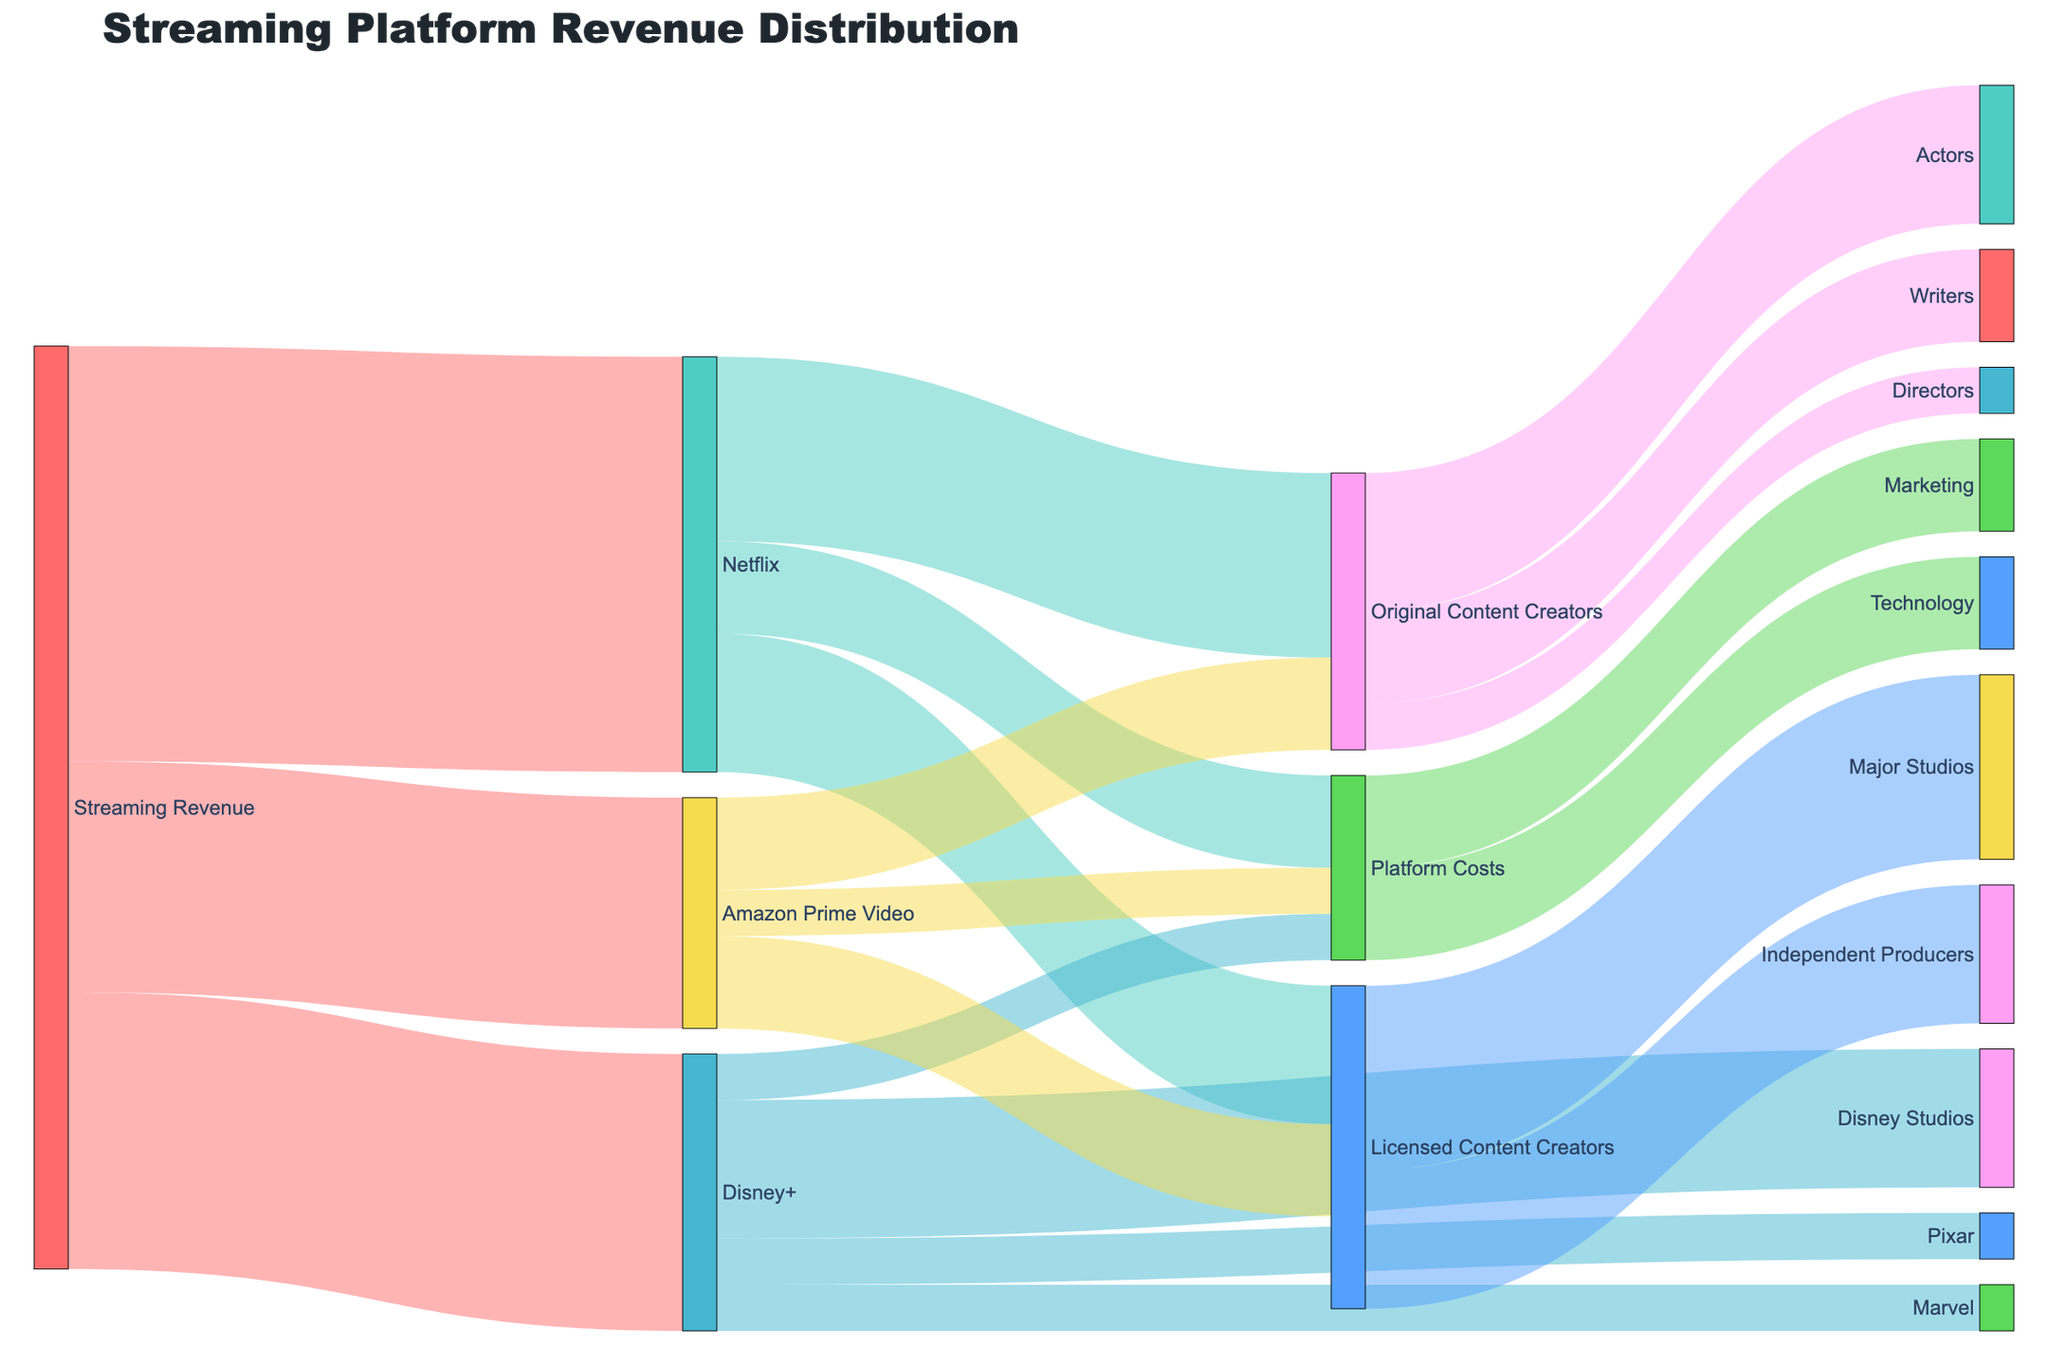What's the total revenue from Streaming Revenue? Summing all values coming from "Streaming Revenue": 45 (Netflix) + 30 (Disney+) + 25 (Amazon Prime Video) = 100
Answer: 100 How much revenue does Netflix generate for Original Content Creators? The value connecting Netflix to Original Content Creators is 20.
Answer: 20 Which platform allocates the most funds to their own Platform Costs? Comparing the values for Platform Costs: Netflix (10), Disney+ (5), Amazon Prime Video (5). Netflix allocates the most.
Answer: Netflix What is the total revenue allocated to Licensed Content Creators across all platforms? Summing all values going to Licensed Content Creators: Netflix (15) + Amazon Prime Video (10) = 25
Answer: 25 What is the difference in funding between Disney Studios and Pixar from Disney+? The value for Disney Studios is 15, and for Pixar is 5. The difference is 15 - 5 = 10.
Answer: 10 What is the proportion of Amazon Prime Video's revenue that goes to Original Content Creators? The value for Original Content Creators is 10 out of a total 25 for Amazon Prime Video. The proportion is 10/25 = 0.4 or 40%.
Answer: 40% Which content creator category receives more funding from Netflix: Original or Licensed Content Creators? Comparing values: Original Content Creators (20) and Licensed Content Creators (15). Original Content Creators receive more.
Answer: Original Content Creators How many different types of content creators receive revenue directly from Netflix? The categories receiving revenue directly from Netflix are Original Content Creators and Licensed Content Creators, which makes 2 types.
Answer: 2 What fraction of total Streaming Revenue goes to Technology and Marketing in Platform Costs? The value for Technology is 10 and for Marketing is 10, totaling 20. Out of the total 100 of Streaming Revenue, the fraction is 20/100 = 0.2 or 20%.
Answer: 20% From all the platforms, which item has the highest single allocation of funds? The item with the highest allocation is Netflix receiving 45 from Streaming Revenue.
Answer: Netflix 